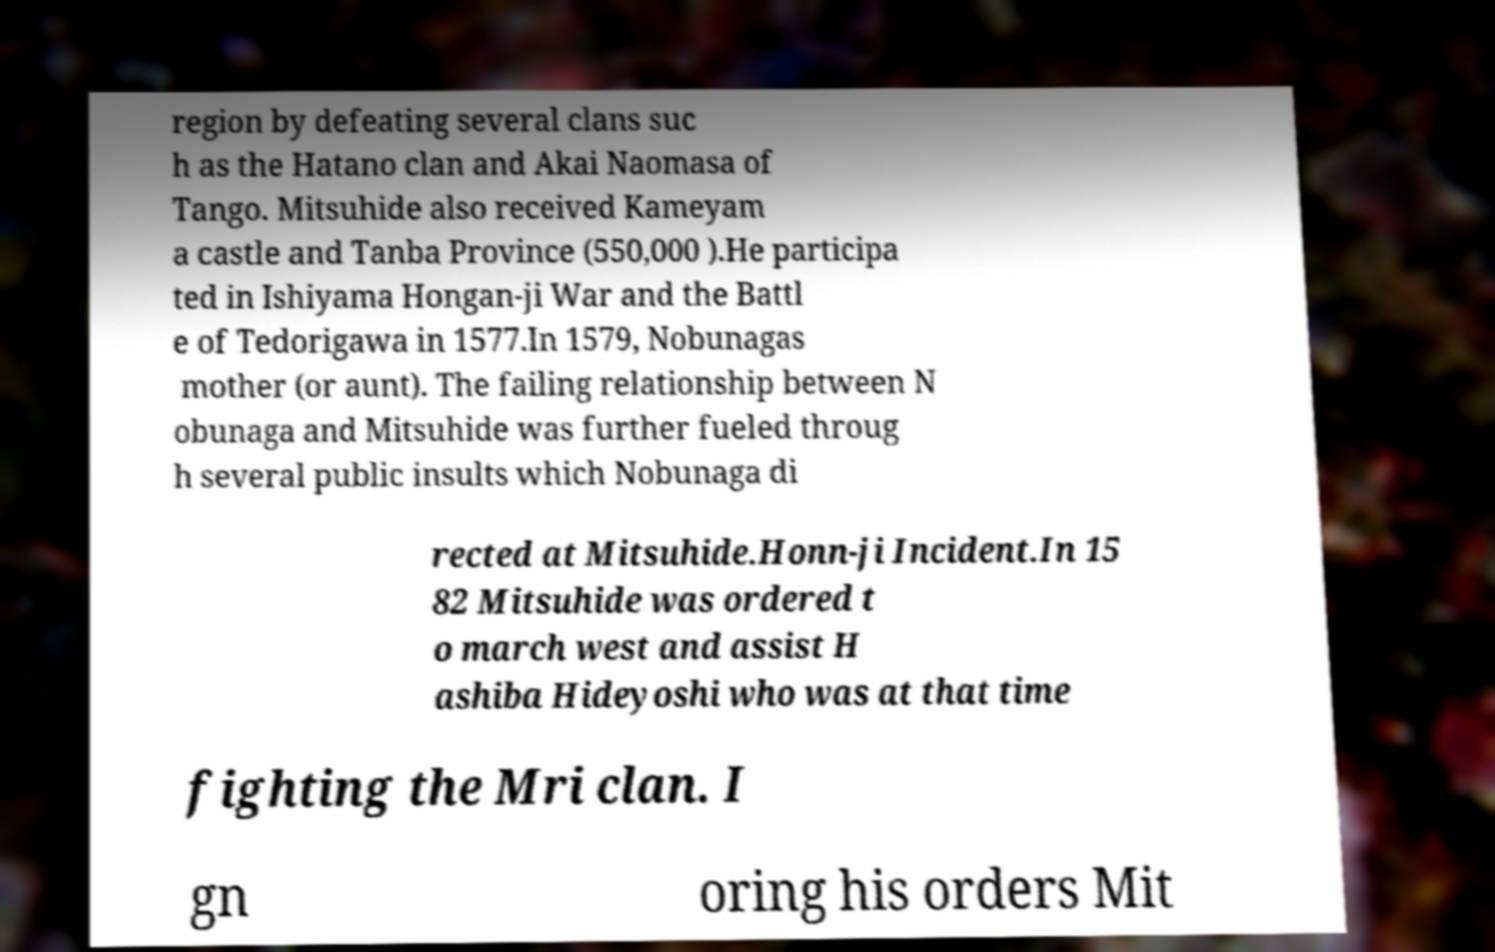Could you extract and type out the text from this image? region by defeating several clans suc h as the Hatano clan and Akai Naomasa of Tango. Mitsuhide also received Kameyam a castle and Tanba Province (550,000 ).He participa ted in Ishiyama Hongan-ji War and the Battl e of Tedorigawa in 1577.In 1579, Nobunagas mother (or aunt). The failing relationship between N obunaga and Mitsuhide was further fueled throug h several public insults which Nobunaga di rected at Mitsuhide.Honn-ji Incident.In 15 82 Mitsuhide was ordered t o march west and assist H ashiba Hideyoshi who was at that time fighting the Mri clan. I gn oring his orders Mit 